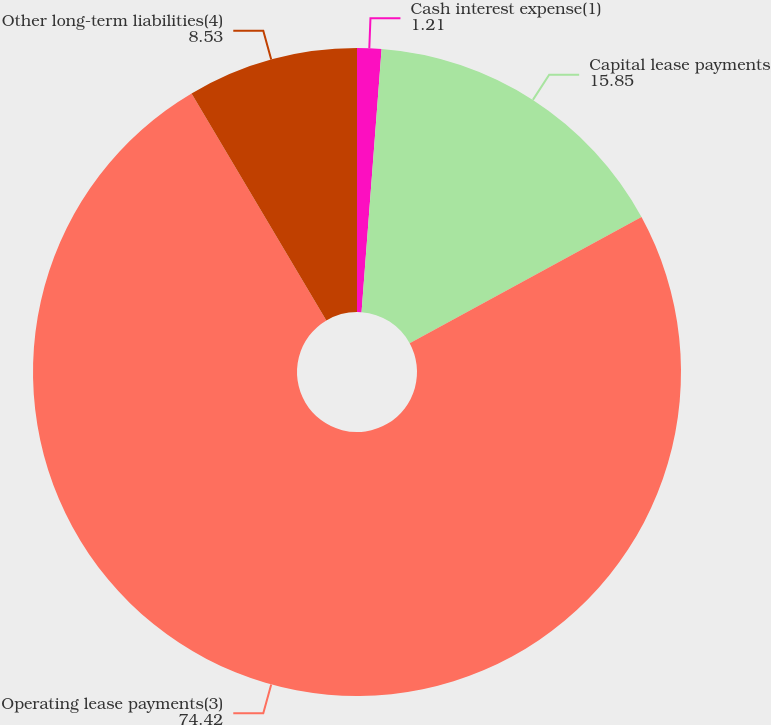Convert chart. <chart><loc_0><loc_0><loc_500><loc_500><pie_chart><fcel>Cash interest expense(1)<fcel>Capital lease payments<fcel>Operating lease payments(3)<fcel>Other long-term liabilities(4)<nl><fcel>1.21%<fcel>15.85%<fcel>74.42%<fcel>8.53%<nl></chart> 